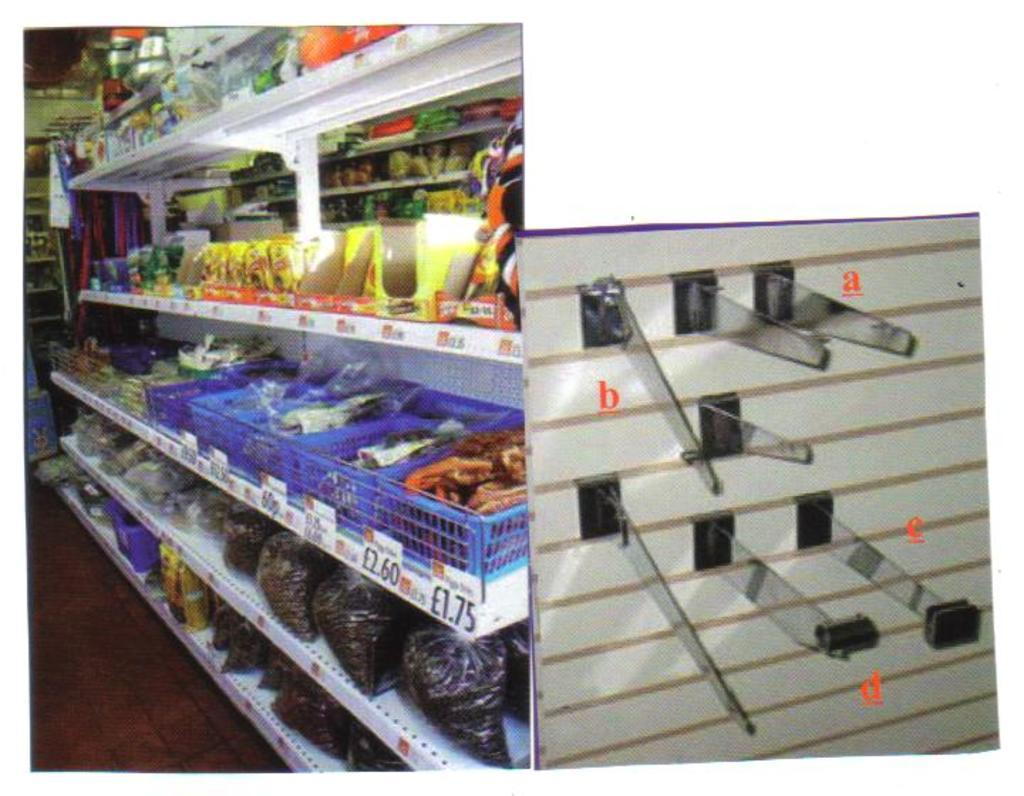<image>
Write a terse but informative summary of the picture. A blue bin contains food that costs 1.75 British pounds. 